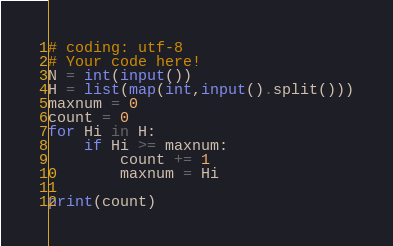Convert code to text. <code><loc_0><loc_0><loc_500><loc_500><_Python_># coding: utf-8
# Your code here!
N = int(input())
H = list(map(int,input().split()))
maxnum = 0
count = 0
for Hi in H:
    if Hi >= maxnum:
        count += 1
        maxnum = Hi

print(count)</code> 